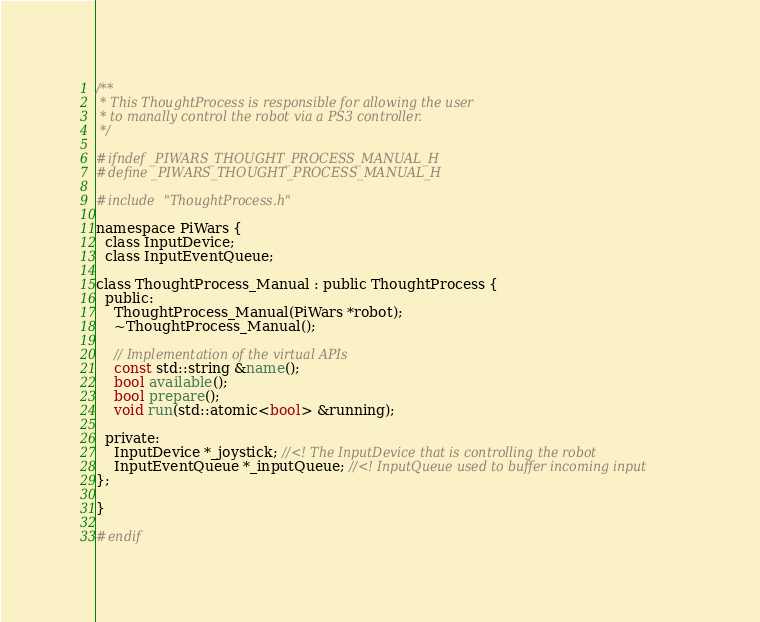Convert code to text. <code><loc_0><loc_0><loc_500><loc_500><_C_>/**
 * This ThoughtProcess is responsible for allowing the user
 * to manally control the robot via a PS3 controller.
 */

#ifndef _PIWARS_THOUGHT_PROCESS_MANUAL_H
#define _PIWARS_THOUGHT_PROCESS_MANUAL_H

#include "ThoughtProcess.h"

namespace PiWars {
  class InputDevice;
  class InputEventQueue;

class ThoughtProcess_Manual : public ThoughtProcess {
  public:
    ThoughtProcess_Manual(PiWars *robot);
    ~ThoughtProcess_Manual();

    // Implementation of the virtual APIs
    const std::string &name();
    bool available();
    bool prepare();
    void run(std::atomic<bool> &running);

  private:
    InputDevice *_joystick; //<! The InputDevice that is controlling the robot
    InputEventQueue *_inputQueue; //<! InputQueue used to buffer incoming input
};

}

#endif
</code> 